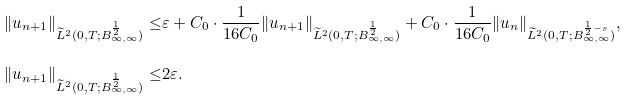<formula> <loc_0><loc_0><loc_500><loc_500>\| u _ { n + 1 } \| _ { \widetilde { L } ^ { 2 } ( 0 , T ; B ^ { \frac { 1 } { 2 } } _ { \infty , \infty } ) } \leq & \varepsilon + C _ { 0 } \cdot \frac { 1 } { 1 6 C _ { 0 } } \| u _ { n + 1 } \| _ { \widetilde { L } ^ { 2 } ( 0 , T ; B ^ { \frac { 1 } { 2 } } _ { \infty , \infty } ) } + C _ { 0 } \cdot \frac { 1 } { 1 6 C _ { 0 } } \| u _ { n } \| _ { \widetilde { L } ^ { 2 } ( 0 , T ; B ^ { \frac { 1 } { 2 } - s } _ { \infty , \infty } ) } , \\ \| u _ { n + 1 } \| _ { \widetilde { L } ^ { 2 } ( 0 , T ; B ^ { \frac { 1 } { 2 } } _ { \infty , \infty } ) } \leq & 2 \varepsilon .</formula> 